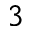<formula> <loc_0><loc_0><loc_500><loc_500>^ { 3 }</formula> 